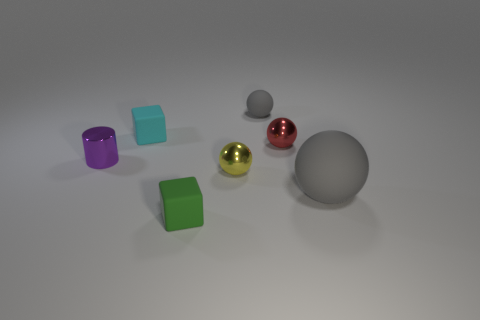Add 3 tiny blue rubber things. How many objects exist? 10 Subtract all cubes. How many objects are left? 5 Add 4 yellow spheres. How many yellow spheres exist? 5 Subtract 0 brown blocks. How many objects are left? 7 Subtract all blue matte cylinders. Subtract all tiny purple metal objects. How many objects are left? 6 Add 1 small yellow balls. How many small yellow balls are left? 2 